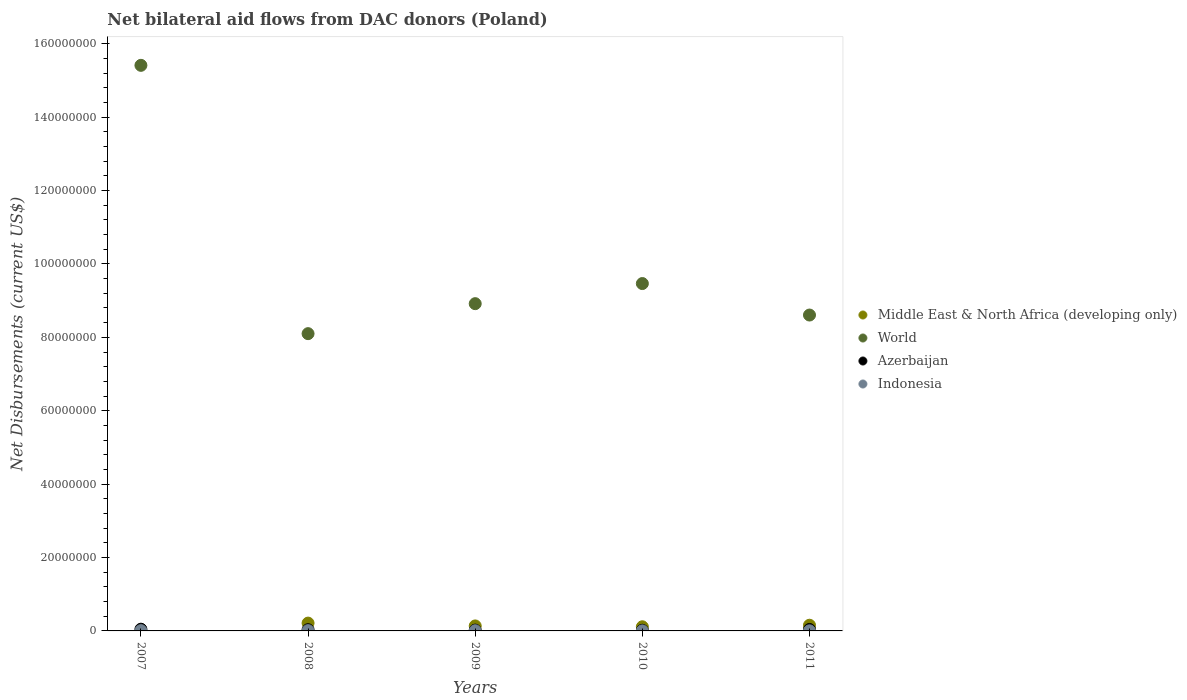How many different coloured dotlines are there?
Make the answer very short. 4. What is the net bilateral aid flows in Middle East & North Africa (developing only) in 2009?
Your answer should be compact. 1.36e+06. Across all years, what is the maximum net bilateral aid flows in Middle East & North Africa (developing only)?
Provide a short and direct response. 2.13e+06. Across all years, what is the minimum net bilateral aid flows in Middle East & North Africa (developing only)?
Your response must be concise. 0. What is the total net bilateral aid flows in Indonesia in the graph?
Your answer should be very brief. 2.50e+05. What is the difference between the net bilateral aid flows in Indonesia in 2007 and that in 2010?
Your answer should be very brief. 7.00e+04. What is the difference between the net bilateral aid flows in World in 2011 and the net bilateral aid flows in Middle East & North Africa (developing only) in 2009?
Make the answer very short. 8.47e+07. What is the average net bilateral aid flows in Middle East & North Africa (developing only) per year?
Make the answer very short. 1.23e+06. In the year 2010, what is the difference between the net bilateral aid flows in Indonesia and net bilateral aid flows in Middle East & North Africa (developing only)?
Offer a terse response. -1.12e+06. What is the ratio of the net bilateral aid flows in World in 2007 to that in 2009?
Give a very brief answer. 1.73. What is the difference between the highest and the lowest net bilateral aid flows in Indonesia?
Give a very brief answer. 7.00e+04. In how many years, is the net bilateral aid flows in World greater than the average net bilateral aid flows in World taken over all years?
Ensure brevity in your answer.  1. Does the net bilateral aid flows in Azerbaijan monotonically increase over the years?
Provide a succinct answer. No. Is the net bilateral aid flows in Azerbaijan strictly greater than the net bilateral aid flows in Indonesia over the years?
Your answer should be compact. Yes. Is the net bilateral aid flows in Indonesia strictly less than the net bilateral aid flows in World over the years?
Your answer should be very brief. Yes. How many dotlines are there?
Make the answer very short. 4. Does the graph contain grids?
Give a very brief answer. No. Where does the legend appear in the graph?
Make the answer very short. Center right. How many legend labels are there?
Give a very brief answer. 4. How are the legend labels stacked?
Your answer should be very brief. Vertical. What is the title of the graph?
Provide a succinct answer. Net bilateral aid flows from DAC donors (Poland). Does "France" appear as one of the legend labels in the graph?
Keep it short and to the point. No. What is the label or title of the Y-axis?
Offer a terse response. Net Disbursements (current US$). What is the Net Disbursements (current US$) of World in 2007?
Provide a short and direct response. 1.54e+08. What is the Net Disbursements (current US$) of Middle East & North Africa (developing only) in 2008?
Your response must be concise. 2.13e+06. What is the Net Disbursements (current US$) of World in 2008?
Your response must be concise. 8.10e+07. What is the Net Disbursements (current US$) in Middle East & North Africa (developing only) in 2009?
Offer a very short reply. 1.36e+06. What is the Net Disbursements (current US$) of World in 2009?
Provide a short and direct response. 8.92e+07. What is the Net Disbursements (current US$) of Azerbaijan in 2009?
Make the answer very short. 2.20e+05. What is the Net Disbursements (current US$) of Indonesia in 2009?
Provide a short and direct response. 5.00e+04. What is the Net Disbursements (current US$) of Middle East & North Africa (developing only) in 2010?
Make the answer very short. 1.13e+06. What is the Net Disbursements (current US$) of World in 2010?
Offer a very short reply. 9.46e+07. What is the Net Disbursements (current US$) in Azerbaijan in 2010?
Keep it short and to the point. 1.80e+05. What is the Net Disbursements (current US$) of Middle East & North Africa (developing only) in 2011?
Provide a short and direct response. 1.55e+06. What is the Net Disbursements (current US$) in World in 2011?
Offer a terse response. 8.61e+07. What is the Net Disbursements (current US$) in Indonesia in 2011?
Make the answer very short. 3.00e+04. Across all years, what is the maximum Net Disbursements (current US$) of Middle East & North Africa (developing only)?
Provide a succinct answer. 2.13e+06. Across all years, what is the maximum Net Disbursements (current US$) in World?
Ensure brevity in your answer.  1.54e+08. Across all years, what is the maximum Net Disbursements (current US$) in Azerbaijan?
Make the answer very short. 4.70e+05. Across all years, what is the minimum Net Disbursements (current US$) in World?
Keep it short and to the point. 8.10e+07. What is the total Net Disbursements (current US$) of Middle East & North Africa (developing only) in the graph?
Give a very brief answer. 6.17e+06. What is the total Net Disbursements (current US$) in World in the graph?
Keep it short and to the point. 5.05e+08. What is the total Net Disbursements (current US$) of Azerbaijan in the graph?
Provide a short and direct response. 1.60e+06. What is the total Net Disbursements (current US$) of Indonesia in the graph?
Your response must be concise. 2.50e+05. What is the difference between the Net Disbursements (current US$) of World in 2007 and that in 2008?
Provide a succinct answer. 7.31e+07. What is the difference between the Net Disbursements (current US$) of Azerbaijan in 2007 and that in 2008?
Your answer should be very brief. 1.40e+05. What is the difference between the Net Disbursements (current US$) in World in 2007 and that in 2009?
Provide a short and direct response. 6.49e+07. What is the difference between the Net Disbursements (current US$) of Azerbaijan in 2007 and that in 2009?
Your response must be concise. 2.50e+05. What is the difference between the Net Disbursements (current US$) of Indonesia in 2007 and that in 2009?
Offer a very short reply. 3.00e+04. What is the difference between the Net Disbursements (current US$) of World in 2007 and that in 2010?
Offer a very short reply. 5.95e+07. What is the difference between the Net Disbursements (current US$) in Azerbaijan in 2007 and that in 2010?
Provide a short and direct response. 2.90e+05. What is the difference between the Net Disbursements (current US$) of Indonesia in 2007 and that in 2010?
Offer a very short reply. 7.00e+04. What is the difference between the Net Disbursements (current US$) in World in 2007 and that in 2011?
Your answer should be compact. 6.80e+07. What is the difference between the Net Disbursements (current US$) in Azerbaijan in 2007 and that in 2011?
Offer a very short reply. 7.00e+04. What is the difference between the Net Disbursements (current US$) in Indonesia in 2007 and that in 2011?
Ensure brevity in your answer.  5.00e+04. What is the difference between the Net Disbursements (current US$) of Middle East & North Africa (developing only) in 2008 and that in 2009?
Offer a terse response. 7.70e+05. What is the difference between the Net Disbursements (current US$) in World in 2008 and that in 2009?
Your answer should be compact. -8.17e+06. What is the difference between the Net Disbursements (current US$) in Azerbaijan in 2008 and that in 2009?
Keep it short and to the point. 1.10e+05. What is the difference between the Net Disbursements (current US$) in Middle East & North Africa (developing only) in 2008 and that in 2010?
Your answer should be very brief. 1.00e+06. What is the difference between the Net Disbursements (current US$) in World in 2008 and that in 2010?
Ensure brevity in your answer.  -1.36e+07. What is the difference between the Net Disbursements (current US$) of Middle East & North Africa (developing only) in 2008 and that in 2011?
Ensure brevity in your answer.  5.80e+05. What is the difference between the Net Disbursements (current US$) in World in 2008 and that in 2011?
Offer a terse response. -5.07e+06. What is the difference between the Net Disbursements (current US$) in Azerbaijan in 2008 and that in 2011?
Your response must be concise. -7.00e+04. What is the difference between the Net Disbursements (current US$) of World in 2009 and that in 2010?
Your response must be concise. -5.48e+06. What is the difference between the Net Disbursements (current US$) in Azerbaijan in 2009 and that in 2010?
Provide a succinct answer. 4.00e+04. What is the difference between the Net Disbursements (current US$) of Middle East & North Africa (developing only) in 2009 and that in 2011?
Your answer should be compact. -1.90e+05. What is the difference between the Net Disbursements (current US$) in World in 2009 and that in 2011?
Offer a terse response. 3.10e+06. What is the difference between the Net Disbursements (current US$) of Azerbaijan in 2009 and that in 2011?
Provide a short and direct response. -1.80e+05. What is the difference between the Net Disbursements (current US$) in Middle East & North Africa (developing only) in 2010 and that in 2011?
Provide a short and direct response. -4.20e+05. What is the difference between the Net Disbursements (current US$) of World in 2010 and that in 2011?
Make the answer very short. 8.58e+06. What is the difference between the Net Disbursements (current US$) in Azerbaijan in 2010 and that in 2011?
Your answer should be compact. -2.20e+05. What is the difference between the Net Disbursements (current US$) of World in 2007 and the Net Disbursements (current US$) of Azerbaijan in 2008?
Give a very brief answer. 1.54e+08. What is the difference between the Net Disbursements (current US$) of World in 2007 and the Net Disbursements (current US$) of Indonesia in 2008?
Provide a short and direct response. 1.54e+08. What is the difference between the Net Disbursements (current US$) of World in 2007 and the Net Disbursements (current US$) of Azerbaijan in 2009?
Ensure brevity in your answer.  1.54e+08. What is the difference between the Net Disbursements (current US$) of World in 2007 and the Net Disbursements (current US$) of Indonesia in 2009?
Your response must be concise. 1.54e+08. What is the difference between the Net Disbursements (current US$) in World in 2007 and the Net Disbursements (current US$) in Azerbaijan in 2010?
Make the answer very short. 1.54e+08. What is the difference between the Net Disbursements (current US$) of World in 2007 and the Net Disbursements (current US$) of Indonesia in 2010?
Make the answer very short. 1.54e+08. What is the difference between the Net Disbursements (current US$) of Azerbaijan in 2007 and the Net Disbursements (current US$) of Indonesia in 2010?
Your answer should be very brief. 4.60e+05. What is the difference between the Net Disbursements (current US$) of World in 2007 and the Net Disbursements (current US$) of Azerbaijan in 2011?
Your answer should be very brief. 1.54e+08. What is the difference between the Net Disbursements (current US$) of World in 2007 and the Net Disbursements (current US$) of Indonesia in 2011?
Provide a succinct answer. 1.54e+08. What is the difference between the Net Disbursements (current US$) in Middle East & North Africa (developing only) in 2008 and the Net Disbursements (current US$) in World in 2009?
Your response must be concise. -8.70e+07. What is the difference between the Net Disbursements (current US$) in Middle East & North Africa (developing only) in 2008 and the Net Disbursements (current US$) in Azerbaijan in 2009?
Your answer should be very brief. 1.91e+06. What is the difference between the Net Disbursements (current US$) of Middle East & North Africa (developing only) in 2008 and the Net Disbursements (current US$) of Indonesia in 2009?
Your answer should be compact. 2.08e+06. What is the difference between the Net Disbursements (current US$) of World in 2008 and the Net Disbursements (current US$) of Azerbaijan in 2009?
Keep it short and to the point. 8.08e+07. What is the difference between the Net Disbursements (current US$) of World in 2008 and the Net Disbursements (current US$) of Indonesia in 2009?
Provide a short and direct response. 8.10e+07. What is the difference between the Net Disbursements (current US$) of Middle East & North Africa (developing only) in 2008 and the Net Disbursements (current US$) of World in 2010?
Your answer should be compact. -9.25e+07. What is the difference between the Net Disbursements (current US$) of Middle East & North Africa (developing only) in 2008 and the Net Disbursements (current US$) of Azerbaijan in 2010?
Provide a short and direct response. 1.95e+06. What is the difference between the Net Disbursements (current US$) in Middle East & North Africa (developing only) in 2008 and the Net Disbursements (current US$) in Indonesia in 2010?
Give a very brief answer. 2.12e+06. What is the difference between the Net Disbursements (current US$) of World in 2008 and the Net Disbursements (current US$) of Azerbaijan in 2010?
Your answer should be compact. 8.08e+07. What is the difference between the Net Disbursements (current US$) of World in 2008 and the Net Disbursements (current US$) of Indonesia in 2010?
Offer a terse response. 8.10e+07. What is the difference between the Net Disbursements (current US$) in Middle East & North Africa (developing only) in 2008 and the Net Disbursements (current US$) in World in 2011?
Keep it short and to the point. -8.39e+07. What is the difference between the Net Disbursements (current US$) in Middle East & North Africa (developing only) in 2008 and the Net Disbursements (current US$) in Azerbaijan in 2011?
Make the answer very short. 1.73e+06. What is the difference between the Net Disbursements (current US$) of Middle East & North Africa (developing only) in 2008 and the Net Disbursements (current US$) of Indonesia in 2011?
Offer a very short reply. 2.10e+06. What is the difference between the Net Disbursements (current US$) of World in 2008 and the Net Disbursements (current US$) of Azerbaijan in 2011?
Make the answer very short. 8.06e+07. What is the difference between the Net Disbursements (current US$) of World in 2008 and the Net Disbursements (current US$) of Indonesia in 2011?
Your answer should be compact. 8.10e+07. What is the difference between the Net Disbursements (current US$) of Middle East & North Africa (developing only) in 2009 and the Net Disbursements (current US$) of World in 2010?
Offer a terse response. -9.33e+07. What is the difference between the Net Disbursements (current US$) of Middle East & North Africa (developing only) in 2009 and the Net Disbursements (current US$) of Azerbaijan in 2010?
Make the answer very short. 1.18e+06. What is the difference between the Net Disbursements (current US$) in Middle East & North Africa (developing only) in 2009 and the Net Disbursements (current US$) in Indonesia in 2010?
Your answer should be compact. 1.35e+06. What is the difference between the Net Disbursements (current US$) of World in 2009 and the Net Disbursements (current US$) of Azerbaijan in 2010?
Provide a short and direct response. 8.90e+07. What is the difference between the Net Disbursements (current US$) of World in 2009 and the Net Disbursements (current US$) of Indonesia in 2010?
Provide a succinct answer. 8.92e+07. What is the difference between the Net Disbursements (current US$) in Middle East & North Africa (developing only) in 2009 and the Net Disbursements (current US$) in World in 2011?
Make the answer very short. -8.47e+07. What is the difference between the Net Disbursements (current US$) of Middle East & North Africa (developing only) in 2009 and the Net Disbursements (current US$) of Azerbaijan in 2011?
Ensure brevity in your answer.  9.60e+05. What is the difference between the Net Disbursements (current US$) in Middle East & North Africa (developing only) in 2009 and the Net Disbursements (current US$) in Indonesia in 2011?
Your answer should be very brief. 1.33e+06. What is the difference between the Net Disbursements (current US$) in World in 2009 and the Net Disbursements (current US$) in Azerbaijan in 2011?
Your answer should be very brief. 8.88e+07. What is the difference between the Net Disbursements (current US$) in World in 2009 and the Net Disbursements (current US$) in Indonesia in 2011?
Provide a short and direct response. 8.91e+07. What is the difference between the Net Disbursements (current US$) in Middle East & North Africa (developing only) in 2010 and the Net Disbursements (current US$) in World in 2011?
Your answer should be compact. -8.49e+07. What is the difference between the Net Disbursements (current US$) in Middle East & North Africa (developing only) in 2010 and the Net Disbursements (current US$) in Azerbaijan in 2011?
Keep it short and to the point. 7.30e+05. What is the difference between the Net Disbursements (current US$) in Middle East & North Africa (developing only) in 2010 and the Net Disbursements (current US$) in Indonesia in 2011?
Make the answer very short. 1.10e+06. What is the difference between the Net Disbursements (current US$) of World in 2010 and the Net Disbursements (current US$) of Azerbaijan in 2011?
Ensure brevity in your answer.  9.42e+07. What is the difference between the Net Disbursements (current US$) of World in 2010 and the Net Disbursements (current US$) of Indonesia in 2011?
Keep it short and to the point. 9.46e+07. What is the average Net Disbursements (current US$) of Middle East & North Africa (developing only) per year?
Your response must be concise. 1.23e+06. What is the average Net Disbursements (current US$) in World per year?
Your answer should be very brief. 1.01e+08. In the year 2007, what is the difference between the Net Disbursements (current US$) of World and Net Disbursements (current US$) of Azerbaijan?
Your answer should be compact. 1.54e+08. In the year 2007, what is the difference between the Net Disbursements (current US$) of World and Net Disbursements (current US$) of Indonesia?
Make the answer very short. 1.54e+08. In the year 2007, what is the difference between the Net Disbursements (current US$) of Azerbaijan and Net Disbursements (current US$) of Indonesia?
Your answer should be very brief. 3.90e+05. In the year 2008, what is the difference between the Net Disbursements (current US$) in Middle East & North Africa (developing only) and Net Disbursements (current US$) in World?
Offer a terse response. -7.89e+07. In the year 2008, what is the difference between the Net Disbursements (current US$) of Middle East & North Africa (developing only) and Net Disbursements (current US$) of Azerbaijan?
Your response must be concise. 1.80e+06. In the year 2008, what is the difference between the Net Disbursements (current US$) of Middle East & North Africa (developing only) and Net Disbursements (current US$) of Indonesia?
Make the answer very short. 2.05e+06. In the year 2008, what is the difference between the Net Disbursements (current US$) of World and Net Disbursements (current US$) of Azerbaijan?
Keep it short and to the point. 8.07e+07. In the year 2008, what is the difference between the Net Disbursements (current US$) in World and Net Disbursements (current US$) in Indonesia?
Provide a succinct answer. 8.09e+07. In the year 2009, what is the difference between the Net Disbursements (current US$) in Middle East & North Africa (developing only) and Net Disbursements (current US$) in World?
Offer a terse response. -8.78e+07. In the year 2009, what is the difference between the Net Disbursements (current US$) of Middle East & North Africa (developing only) and Net Disbursements (current US$) of Azerbaijan?
Give a very brief answer. 1.14e+06. In the year 2009, what is the difference between the Net Disbursements (current US$) of Middle East & North Africa (developing only) and Net Disbursements (current US$) of Indonesia?
Your answer should be compact. 1.31e+06. In the year 2009, what is the difference between the Net Disbursements (current US$) in World and Net Disbursements (current US$) in Azerbaijan?
Offer a very short reply. 8.90e+07. In the year 2009, what is the difference between the Net Disbursements (current US$) in World and Net Disbursements (current US$) in Indonesia?
Give a very brief answer. 8.91e+07. In the year 2010, what is the difference between the Net Disbursements (current US$) in Middle East & North Africa (developing only) and Net Disbursements (current US$) in World?
Ensure brevity in your answer.  -9.35e+07. In the year 2010, what is the difference between the Net Disbursements (current US$) of Middle East & North Africa (developing only) and Net Disbursements (current US$) of Azerbaijan?
Provide a succinct answer. 9.50e+05. In the year 2010, what is the difference between the Net Disbursements (current US$) of Middle East & North Africa (developing only) and Net Disbursements (current US$) of Indonesia?
Your answer should be very brief. 1.12e+06. In the year 2010, what is the difference between the Net Disbursements (current US$) of World and Net Disbursements (current US$) of Azerbaijan?
Ensure brevity in your answer.  9.45e+07. In the year 2010, what is the difference between the Net Disbursements (current US$) of World and Net Disbursements (current US$) of Indonesia?
Ensure brevity in your answer.  9.46e+07. In the year 2011, what is the difference between the Net Disbursements (current US$) in Middle East & North Africa (developing only) and Net Disbursements (current US$) in World?
Ensure brevity in your answer.  -8.45e+07. In the year 2011, what is the difference between the Net Disbursements (current US$) in Middle East & North Africa (developing only) and Net Disbursements (current US$) in Azerbaijan?
Make the answer very short. 1.15e+06. In the year 2011, what is the difference between the Net Disbursements (current US$) in Middle East & North Africa (developing only) and Net Disbursements (current US$) in Indonesia?
Keep it short and to the point. 1.52e+06. In the year 2011, what is the difference between the Net Disbursements (current US$) of World and Net Disbursements (current US$) of Azerbaijan?
Your answer should be very brief. 8.57e+07. In the year 2011, what is the difference between the Net Disbursements (current US$) in World and Net Disbursements (current US$) in Indonesia?
Provide a short and direct response. 8.60e+07. In the year 2011, what is the difference between the Net Disbursements (current US$) in Azerbaijan and Net Disbursements (current US$) in Indonesia?
Offer a terse response. 3.70e+05. What is the ratio of the Net Disbursements (current US$) in World in 2007 to that in 2008?
Give a very brief answer. 1.9. What is the ratio of the Net Disbursements (current US$) in Azerbaijan in 2007 to that in 2008?
Keep it short and to the point. 1.42. What is the ratio of the Net Disbursements (current US$) of Indonesia in 2007 to that in 2008?
Offer a very short reply. 1. What is the ratio of the Net Disbursements (current US$) in World in 2007 to that in 2009?
Provide a succinct answer. 1.73. What is the ratio of the Net Disbursements (current US$) of Azerbaijan in 2007 to that in 2009?
Make the answer very short. 2.14. What is the ratio of the Net Disbursements (current US$) of Indonesia in 2007 to that in 2009?
Ensure brevity in your answer.  1.6. What is the ratio of the Net Disbursements (current US$) in World in 2007 to that in 2010?
Make the answer very short. 1.63. What is the ratio of the Net Disbursements (current US$) of Azerbaijan in 2007 to that in 2010?
Give a very brief answer. 2.61. What is the ratio of the Net Disbursements (current US$) in Indonesia in 2007 to that in 2010?
Provide a short and direct response. 8. What is the ratio of the Net Disbursements (current US$) in World in 2007 to that in 2011?
Give a very brief answer. 1.79. What is the ratio of the Net Disbursements (current US$) of Azerbaijan in 2007 to that in 2011?
Keep it short and to the point. 1.18. What is the ratio of the Net Disbursements (current US$) of Indonesia in 2007 to that in 2011?
Your answer should be compact. 2.67. What is the ratio of the Net Disbursements (current US$) of Middle East & North Africa (developing only) in 2008 to that in 2009?
Offer a terse response. 1.57. What is the ratio of the Net Disbursements (current US$) in World in 2008 to that in 2009?
Provide a succinct answer. 0.91. What is the ratio of the Net Disbursements (current US$) of Middle East & North Africa (developing only) in 2008 to that in 2010?
Provide a succinct answer. 1.89. What is the ratio of the Net Disbursements (current US$) in World in 2008 to that in 2010?
Ensure brevity in your answer.  0.86. What is the ratio of the Net Disbursements (current US$) of Azerbaijan in 2008 to that in 2010?
Provide a short and direct response. 1.83. What is the ratio of the Net Disbursements (current US$) in Middle East & North Africa (developing only) in 2008 to that in 2011?
Your answer should be very brief. 1.37. What is the ratio of the Net Disbursements (current US$) of World in 2008 to that in 2011?
Offer a terse response. 0.94. What is the ratio of the Net Disbursements (current US$) of Azerbaijan in 2008 to that in 2011?
Provide a succinct answer. 0.82. What is the ratio of the Net Disbursements (current US$) in Indonesia in 2008 to that in 2011?
Give a very brief answer. 2.67. What is the ratio of the Net Disbursements (current US$) in Middle East & North Africa (developing only) in 2009 to that in 2010?
Ensure brevity in your answer.  1.2. What is the ratio of the Net Disbursements (current US$) of World in 2009 to that in 2010?
Make the answer very short. 0.94. What is the ratio of the Net Disbursements (current US$) in Azerbaijan in 2009 to that in 2010?
Your answer should be very brief. 1.22. What is the ratio of the Net Disbursements (current US$) in Middle East & North Africa (developing only) in 2009 to that in 2011?
Ensure brevity in your answer.  0.88. What is the ratio of the Net Disbursements (current US$) in World in 2009 to that in 2011?
Keep it short and to the point. 1.04. What is the ratio of the Net Disbursements (current US$) of Azerbaijan in 2009 to that in 2011?
Make the answer very short. 0.55. What is the ratio of the Net Disbursements (current US$) of Indonesia in 2009 to that in 2011?
Offer a very short reply. 1.67. What is the ratio of the Net Disbursements (current US$) of Middle East & North Africa (developing only) in 2010 to that in 2011?
Your answer should be very brief. 0.73. What is the ratio of the Net Disbursements (current US$) in World in 2010 to that in 2011?
Offer a terse response. 1.1. What is the ratio of the Net Disbursements (current US$) of Azerbaijan in 2010 to that in 2011?
Provide a short and direct response. 0.45. What is the ratio of the Net Disbursements (current US$) of Indonesia in 2010 to that in 2011?
Your answer should be very brief. 0.33. What is the difference between the highest and the second highest Net Disbursements (current US$) in Middle East & North Africa (developing only)?
Make the answer very short. 5.80e+05. What is the difference between the highest and the second highest Net Disbursements (current US$) of World?
Offer a terse response. 5.95e+07. What is the difference between the highest and the second highest Net Disbursements (current US$) of Azerbaijan?
Provide a short and direct response. 7.00e+04. What is the difference between the highest and the second highest Net Disbursements (current US$) in Indonesia?
Give a very brief answer. 0. What is the difference between the highest and the lowest Net Disbursements (current US$) in Middle East & North Africa (developing only)?
Give a very brief answer. 2.13e+06. What is the difference between the highest and the lowest Net Disbursements (current US$) of World?
Your answer should be compact. 7.31e+07. What is the difference between the highest and the lowest Net Disbursements (current US$) of Azerbaijan?
Your answer should be very brief. 2.90e+05. What is the difference between the highest and the lowest Net Disbursements (current US$) in Indonesia?
Ensure brevity in your answer.  7.00e+04. 